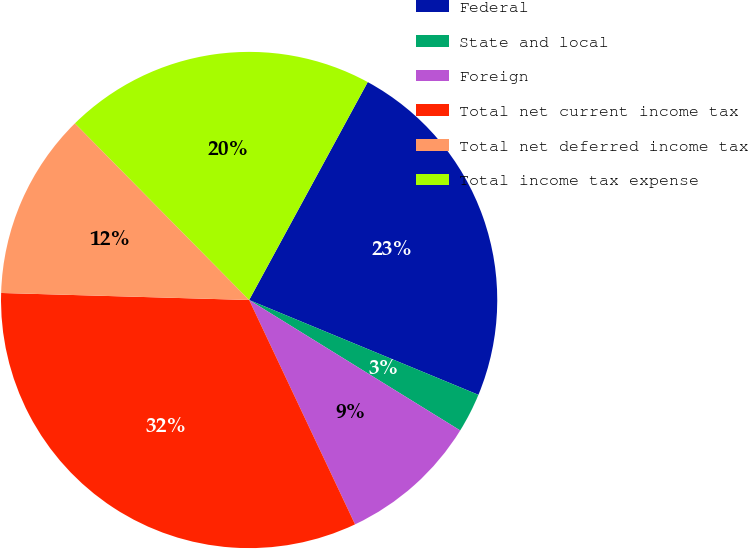Convert chart to OTSL. <chart><loc_0><loc_0><loc_500><loc_500><pie_chart><fcel>Federal<fcel>State and local<fcel>Foreign<fcel>Total net current income tax<fcel>Total net deferred income tax<fcel>Total income tax expense<nl><fcel>23.31%<fcel>2.57%<fcel>9.17%<fcel>32.47%<fcel>12.16%<fcel>20.32%<nl></chart> 